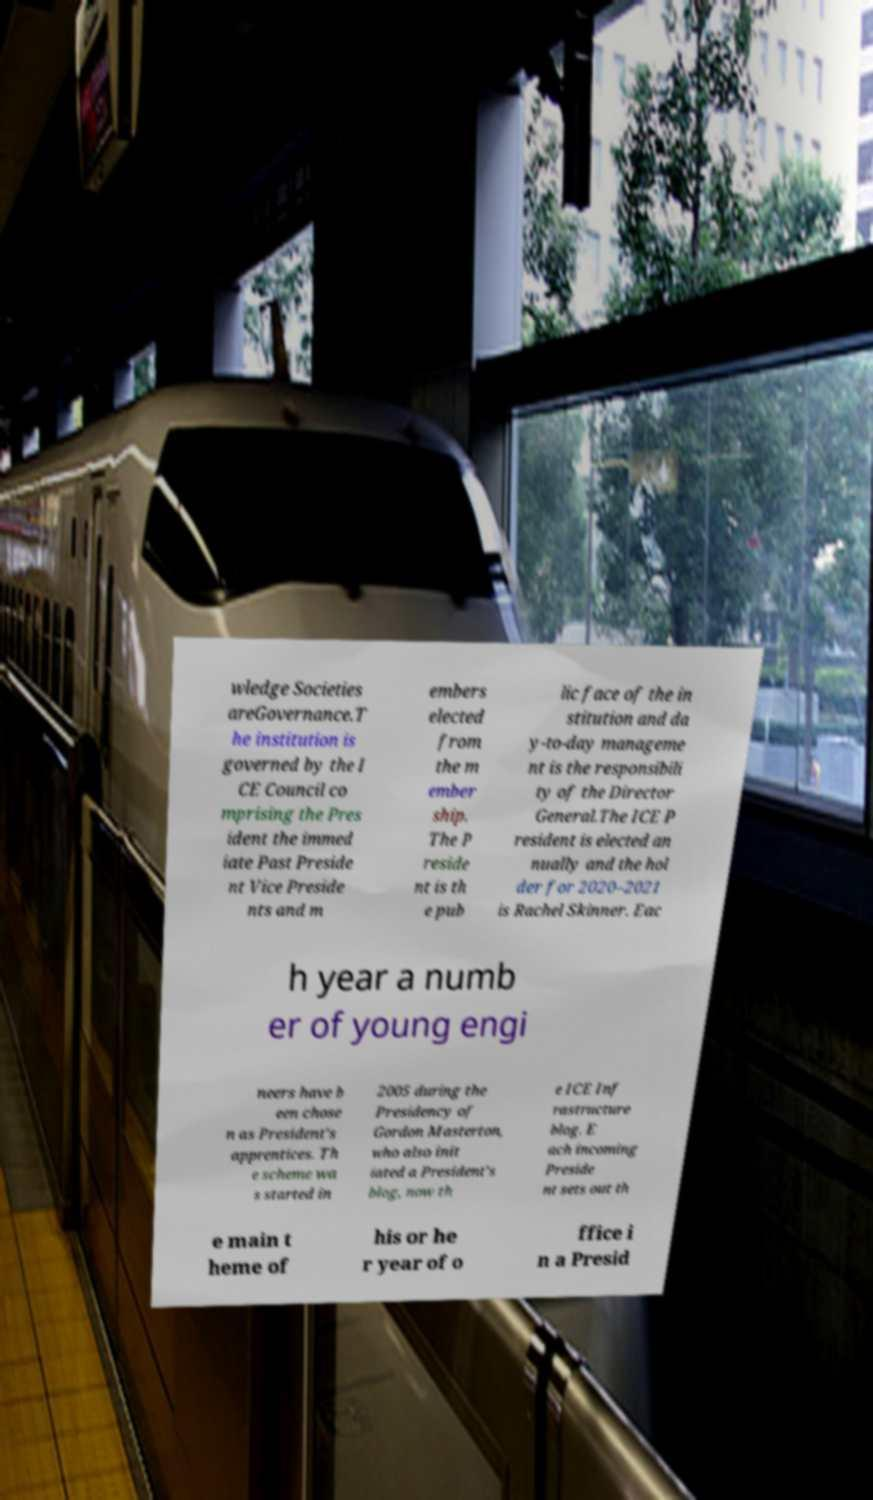There's text embedded in this image that I need extracted. Can you transcribe it verbatim? wledge Societies areGovernance.T he institution is governed by the I CE Council co mprising the Pres ident the immed iate Past Preside nt Vice Preside nts and m embers elected from the m ember ship. The P reside nt is th e pub lic face of the in stitution and da y-to-day manageme nt is the responsibili ty of the Director General.The ICE P resident is elected an nually and the hol der for 2020–2021 is Rachel Skinner. Eac h year a numb er of young engi neers have b een chose n as President's apprentices. Th e scheme wa s started in 2005 during the Presidency of Gordon Masterton, who also init iated a President's blog, now th e ICE Inf rastructure blog. E ach incoming Preside nt sets out th e main t heme of his or he r year of o ffice i n a Presid 